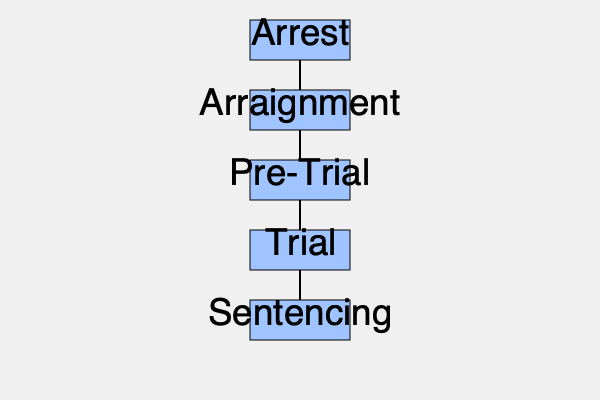Based on the flowchart, what is the stage that immediately follows the "Pre-Trial" phase in a criminal trial process? To answer this question, let's follow the flowchart step-by-step:

1. The flowchart shows the main stages of a criminal trial process.
2. The stages are presented in a vertical sequence, indicating the order in which they occur.
3. The stages shown are: Arrest, Arraignment, Pre-Trial, Trial, and Sentencing.
4. Each stage is connected to the next by a vertical line.
5. We need to identify what comes immediately after the "Pre-Trial" stage.
6. Looking at the flowchart, we can see that directly below "Pre-Trial" is the "Trial" stage.
7. The vertical line connecting "Pre-Trial" to "Trial" confirms that "Trial" is the next immediate stage in the process.

Therefore, based on this flowchart, the stage that immediately follows the "Pre-Trial" phase in a criminal trial process is the "Trial" stage.
Answer: Trial 